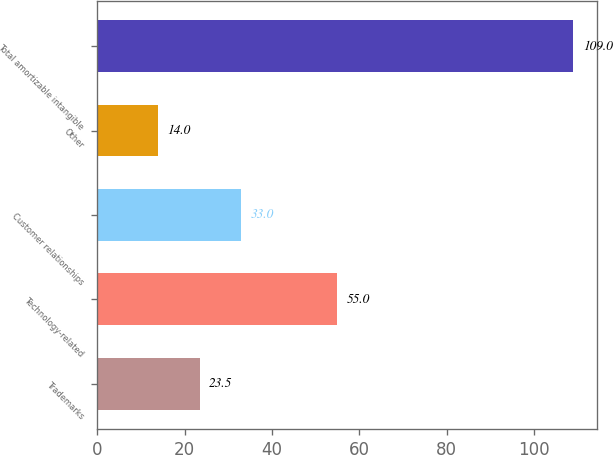Convert chart. <chart><loc_0><loc_0><loc_500><loc_500><bar_chart><fcel>Trademarks<fcel>Technology-related<fcel>Customer relationships<fcel>Other<fcel>Total amortizable intangible<nl><fcel>23.5<fcel>55<fcel>33<fcel>14<fcel>109<nl></chart> 